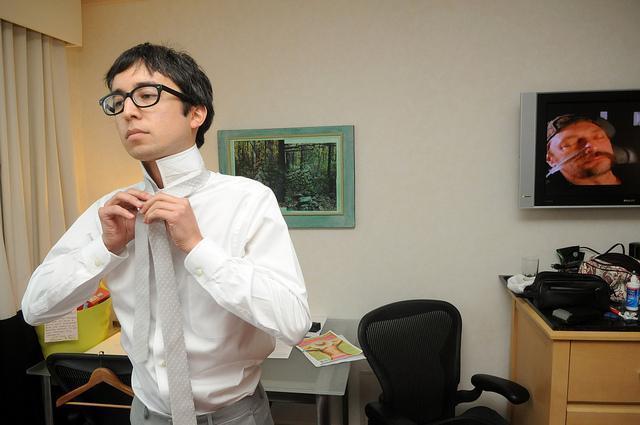What color theme is the man with the the tie trying to achieve with his outfit?
Pick the correct solution from the four options below to address the question.
Options: White, blue, black, grey. Grey. 